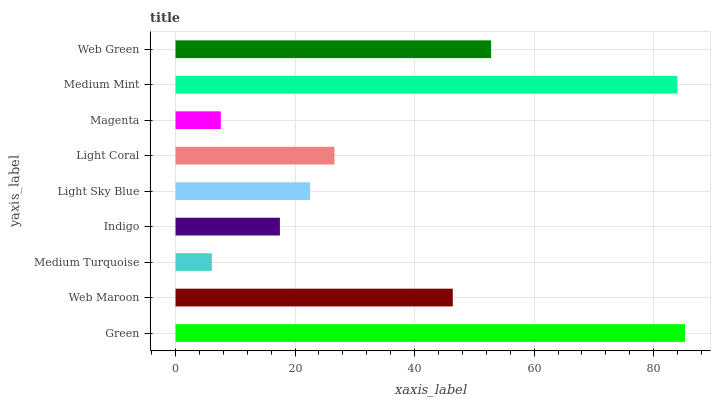Is Medium Turquoise the minimum?
Answer yes or no. Yes. Is Green the maximum?
Answer yes or no. Yes. Is Web Maroon the minimum?
Answer yes or no. No. Is Web Maroon the maximum?
Answer yes or no. No. Is Green greater than Web Maroon?
Answer yes or no. Yes. Is Web Maroon less than Green?
Answer yes or no. Yes. Is Web Maroon greater than Green?
Answer yes or no. No. Is Green less than Web Maroon?
Answer yes or no. No. Is Light Coral the high median?
Answer yes or no. Yes. Is Light Coral the low median?
Answer yes or no. Yes. Is Medium Turquoise the high median?
Answer yes or no. No. Is Green the low median?
Answer yes or no. No. 